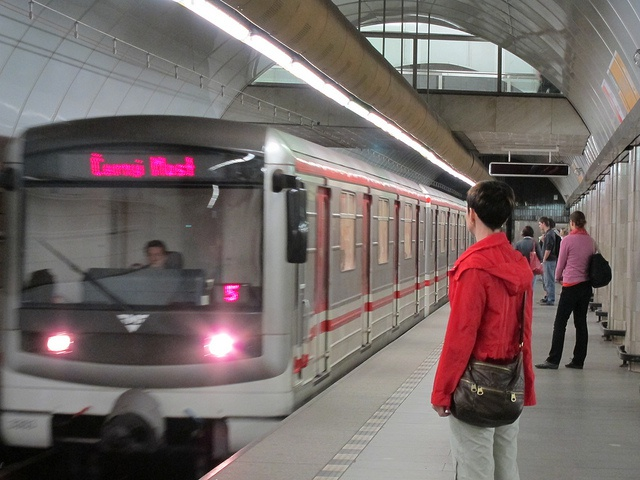Describe the objects in this image and their specific colors. I can see train in gray, black, and darkgray tones, people in gray, brown, darkgray, maroon, and black tones, people in gray, black, brown, and maroon tones, handbag in gray, black, and maroon tones, and people in gray, black, and darkblue tones in this image. 